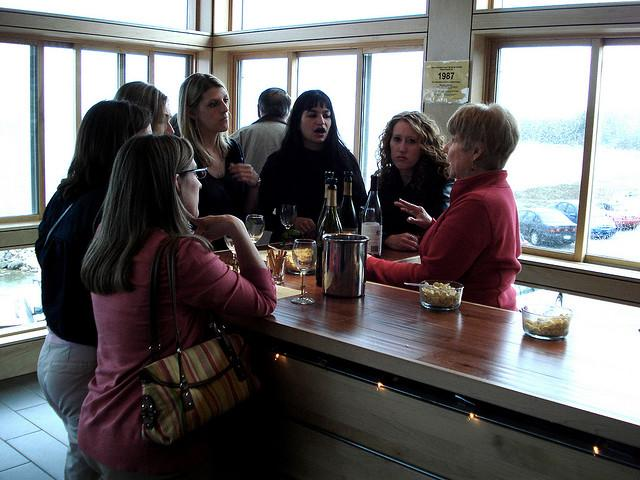What do the ladies here discuss? Please explain your reasoning. wine. The ladies are near wine bottles. 